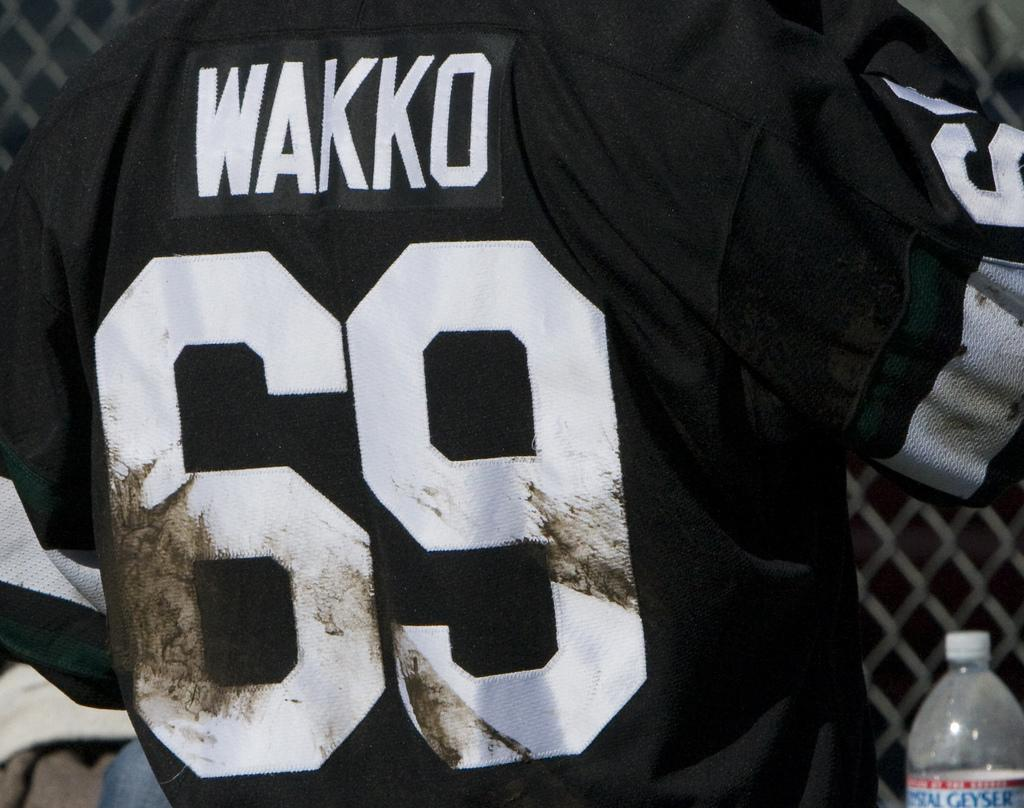<image>
Describe the image concisely. A jersey is black and has the number 69 on the back of it. 